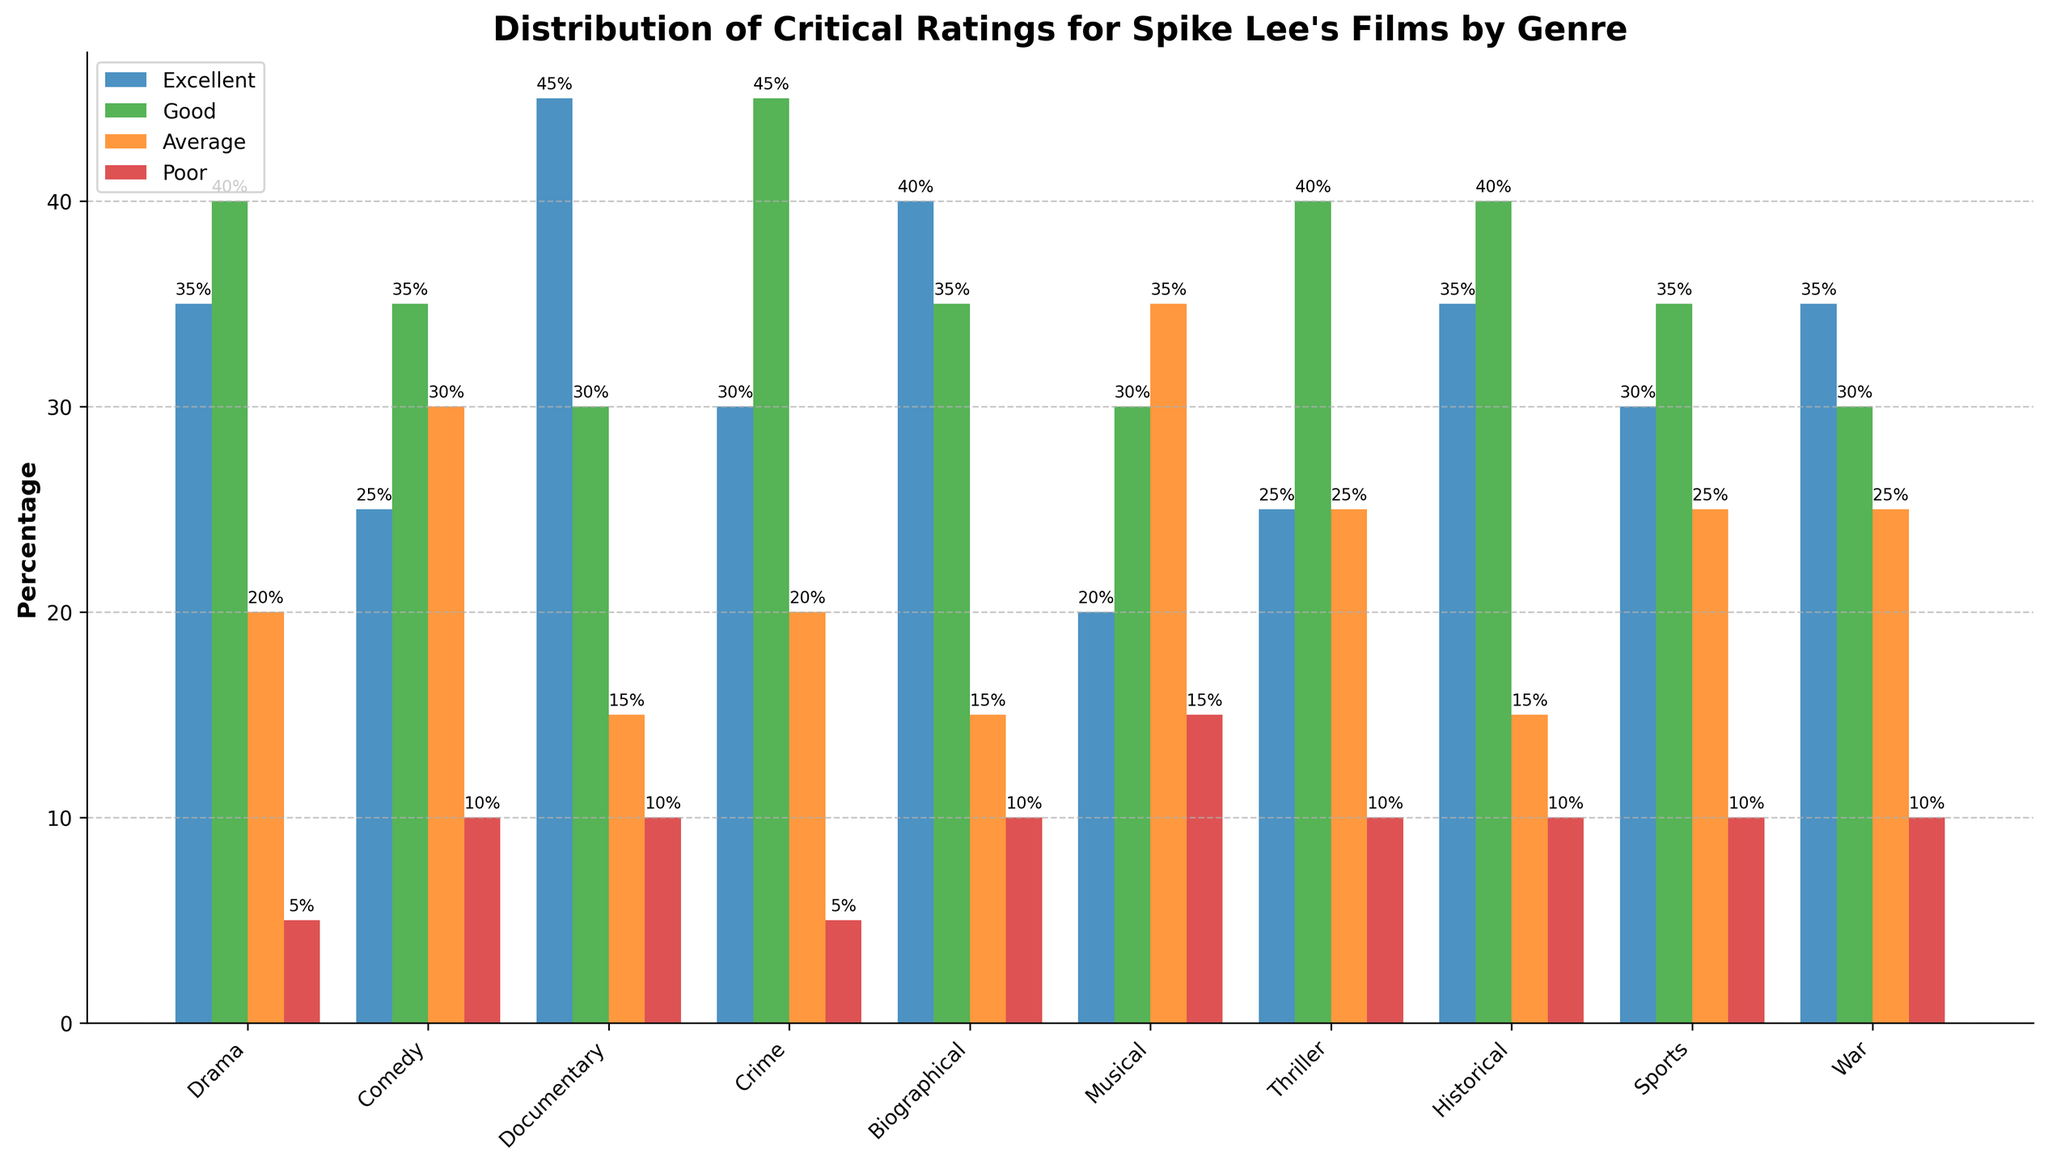what genre has the highest percentage of excellent ratings? The chart shows various bars for each genre, with blue bars representing excellent ratings. The Documentary genre has the tallest blue bar, indicating it has the highest percentage of excellent ratings.
Answer: Documentary which genre has the lowest percentage of poor ratings? The red bars in the chart represent poor ratings. The genres with the shortest red bars are Drama and Crime, both with a poor rating percentage of 5%.
Answer: Drama and Crime how does the percentage of average ratings in the musical genre compare to that in the sports genre? The chart shows that the percentage of average ratings (represented by orange bars) in the Musical genre is 35%, while that in the Sports genre is 25%. 35% is greater than 25%, so the percentage of average ratings in the Musical genre is higher.
Answer: The Musical genre has a higher percentage of average ratings what is the combined percentage of good and excellent ratings for the historical genre? For the Historical genre, the chart shows a green bar for good ratings and a blue bar for excellent ratings. The percentages are 40% (good) and 35% (excellent). Adding these gives 40% + 35% = 75%.
Answer: 75% which genres have an equal percentage of good ratings? The green bars represent good ratings. The chart shows that the genres Drama, Crime, Historical, and Thriller each have a green bar with a 40% value.
Answer: Drama, Crime, Historical, and Thriller compare the percentage of poor ratings between war and comedy genres. Which one has a higher percentage? The red bars represent poor ratings. The chart shows that the War genre has 10% poor ratings, and the Comedy genre also has 10% poor ratings. Both have the same percentage.
Answer: They are equal which genre has the smallest difference between excellent and poor ratings? To find the smallest difference, we look at the blue (excellent) and red (poor) bars for each genre. The smallest difference is in the Drama genre, with 35% excellent and 5% poor, making the difference 35% - 5% = 30%.
Answer: Drama what is the average percentage of poor ratings across all genres? To calculate the average, add all the poor ratings percentages: 5% (Drama) + 10% (Comedy) + 10% (Documentary) + 5% (Crime) + 10% (Biographical) + 15% (Musical) + 10% (Thriller) + 10% (Historical) + 10% (Sports) + 10% (War) = 95%. Divide by the number of genres (10): 95% / 10 = 9.5%.
Answer: 9.5% which genre has more excellent ratings than the cumulative percentage of poor ratings in all genres? The genre with 45% excellent ratings (Documentary) compared to the sum of all poor ratings (5% Drama + 10% Comedy + 10% Documentary + 5% Crime + 10% Biographical + 15% Musical + 10% Thriller + 10% Historical + 10% Sports + 10% War), which is 95%. Documentary genre does not exceed the cumulative poor ratings, but Biographical with 40% does, as the sum excluding Biographical and Documentary’s poor ratings is 70%.
Answer: None, if summing poor with their own 45% compare the sum percentage of good and average ratings between the biographical and sports genres. For Biographical: good is 35% and average is 15%. Their sum is 35% + 15% = 50%. For Sports: good is 35% and average is 25%. Their sum is 35% + 25% = 60%. Sports have a higher total of good and average ratings.
Answer: Sports 